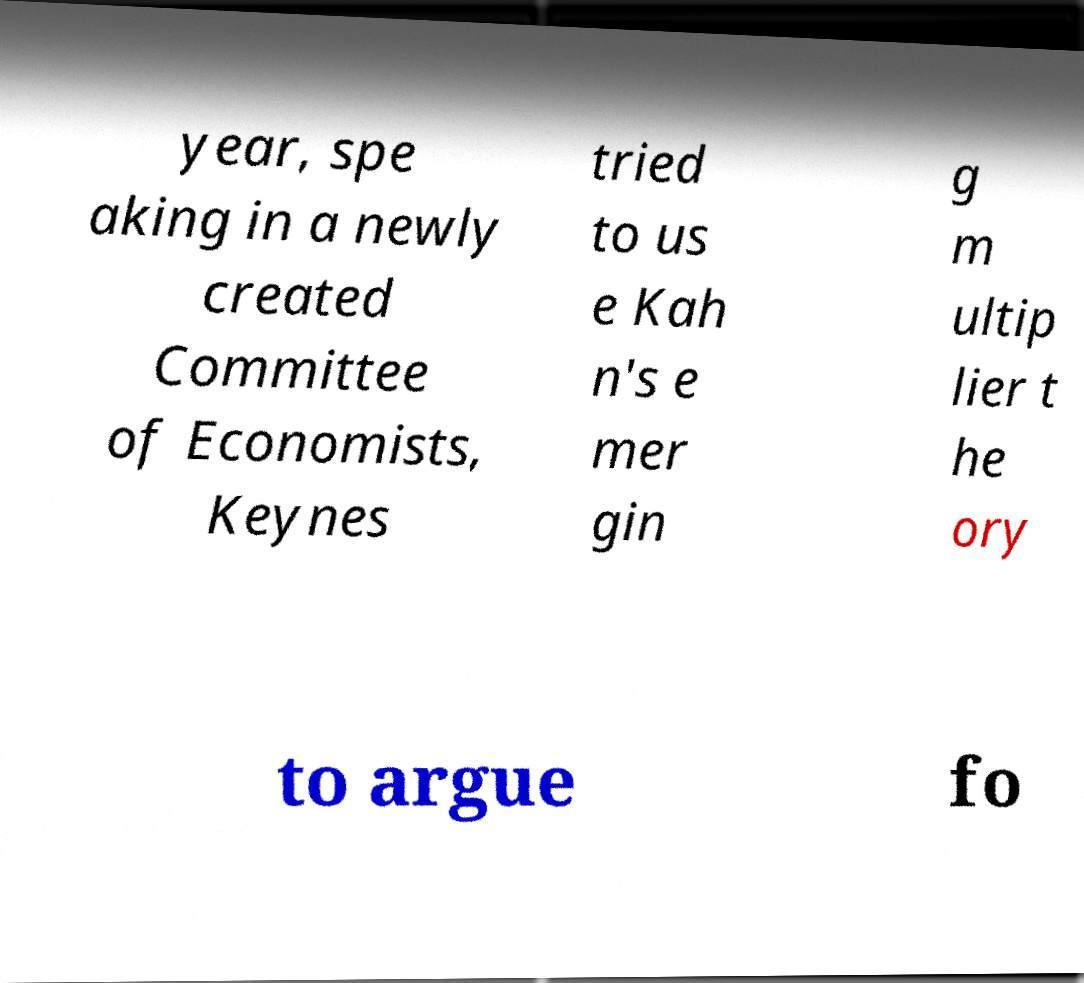Could you assist in decoding the text presented in this image and type it out clearly? year, spe aking in a newly created Committee of Economists, Keynes tried to us e Kah n's e mer gin g m ultip lier t he ory to argue fo 